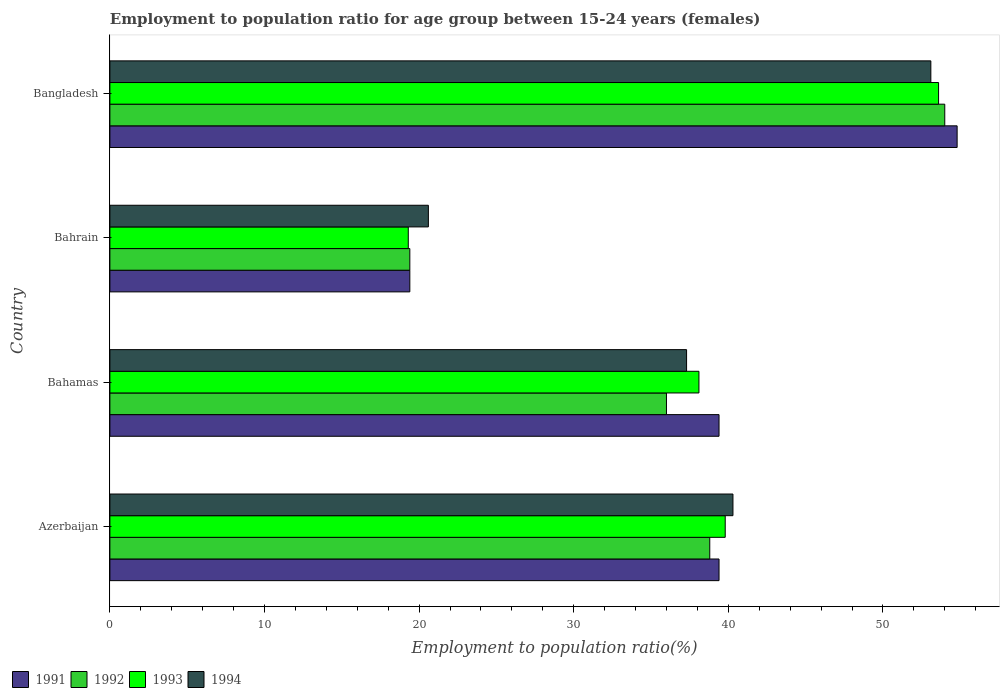What is the label of the 4th group of bars from the top?
Make the answer very short. Azerbaijan. In how many cases, is the number of bars for a given country not equal to the number of legend labels?
Make the answer very short. 0. What is the employment to population ratio in 1994 in Bangladesh?
Ensure brevity in your answer.  53.1. Across all countries, what is the minimum employment to population ratio in 1992?
Offer a very short reply. 19.4. In which country was the employment to population ratio in 1992 maximum?
Your response must be concise. Bangladesh. In which country was the employment to population ratio in 1993 minimum?
Your answer should be very brief. Bahrain. What is the total employment to population ratio in 1992 in the graph?
Ensure brevity in your answer.  148.2. What is the difference between the employment to population ratio in 1993 in Bahrain and that in Bangladesh?
Your answer should be compact. -34.3. What is the difference between the employment to population ratio in 1994 in Bahrain and the employment to population ratio in 1992 in Bangladesh?
Your answer should be compact. -33.4. What is the average employment to population ratio in 1993 per country?
Your answer should be very brief. 37.7. What is the difference between the employment to population ratio in 1992 and employment to population ratio in 1994 in Bahrain?
Your response must be concise. -1.2. In how many countries, is the employment to population ratio in 1994 greater than 20 %?
Your response must be concise. 4. What is the ratio of the employment to population ratio in 1992 in Azerbaijan to that in Bahrain?
Keep it short and to the point. 2. Is the employment to population ratio in 1994 in Azerbaijan less than that in Bahamas?
Give a very brief answer. No. What is the difference between the highest and the second highest employment to population ratio in 1992?
Keep it short and to the point. 15.2. What is the difference between the highest and the lowest employment to population ratio in 1993?
Make the answer very short. 34.3. Is the sum of the employment to population ratio in 1993 in Azerbaijan and Bahrain greater than the maximum employment to population ratio in 1992 across all countries?
Your response must be concise. Yes. What does the 4th bar from the bottom in Bangladesh represents?
Offer a very short reply. 1994. How many bars are there?
Offer a terse response. 16. Are all the bars in the graph horizontal?
Provide a succinct answer. Yes. How many countries are there in the graph?
Give a very brief answer. 4. Does the graph contain grids?
Provide a short and direct response. No. Where does the legend appear in the graph?
Keep it short and to the point. Bottom left. How many legend labels are there?
Provide a short and direct response. 4. What is the title of the graph?
Your answer should be compact. Employment to population ratio for age group between 15-24 years (females). What is the label or title of the X-axis?
Keep it short and to the point. Employment to population ratio(%). What is the Employment to population ratio(%) of 1991 in Azerbaijan?
Ensure brevity in your answer.  39.4. What is the Employment to population ratio(%) of 1992 in Azerbaijan?
Keep it short and to the point. 38.8. What is the Employment to population ratio(%) of 1993 in Azerbaijan?
Your answer should be very brief. 39.8. What is the Employment to population ratio(%) of 1994 in Azerbaijan?
Ensure brevity in your answer.  40.3. What is the Employment to population ratio(%) of 1991 in Bahamas?
Provide a succinct answer. 39.4. What is the Employment to population ratio(%) in 1993 in Bahamas?
Your response must be concise. 38.1. What is the Employment to population ratio(%) in 1994 in Bahamas?
Your response must be concise. 37.3. What is the Employment to population ratio(%) of 1991 in Bahrain?
Your answer should be compact. 19.4. What is the Employment to population ratio(%) of 1992 in Bahrain?
Offer a terse response. 19.4. What is the Employment to population ratio(%) in 1993 in Bahrain?
Provide a short and direct response. 19.3. What is the Employment to population ratio(%) of 1994 in Bahrain?
Provide a succinct answer. 20.6. What is the Employment to population ratio(%) of 1991 in Bangladesh?
Keep it short and to the point. 54.8. What is the Employment to population ratio(%) of 1992 in Bangladesh?
Provide a short and direct response. 54. What is the Employment to population ratio(%) of 1993 in Bangladesh?
Provide a short and direct response. 53.6. What is the Employment to population ratio(%) in 1994 in Bangladesh?
Your answer should be very brief. 53.1. Across all countries, what is the maximum Employment to population ratio(%) in 1991?
Make the answer very short. 54.8. Across all countries, what is the maximum Employment to population ratio(%) of 1992?
Provide a short and direct response. 54. Across all countries, what is the maximum Employment to population ratio(%) in 1993?
Ensure brevity in your answer.  53.6. Across all countries, what is the maximum Employment to population ratio(%) of 1994?
Your answer should be very brief. 53.1. Across all countries, what is the minimum Employment to population ratio(%) of 1991?
Provide a succinct answer. 19.4. Across all countries, what is the minimum Employment to population ratio(%) in 1992?
Offer a very short reply. 19.4. Across all countries, what is the minimum Employment to population ratio(%) of 1993?
Keep it short and to the point. 19.3. Across all countries, what is the minimum Employment to population ratio(%) of 1994?
Offer a very short reply. 20.6. What is the total Employment to population ratio(%) in 1991 in the graph?
Offer a very short reply. 153. What is the total Employment to population ratio(%) in 1992 in the graph?
Provide a succinct answer. 148.2. What is the total Employment to population ratio(%) of 1993 in the graph?
Keep it short and to the point. 150.8. What is the total Employment to population ratio(%) in 1994 in the graph?
Your response must be concise. 151.3. What is the difference between the Employment to population ratio(%) of 1991 in Azerbaijan and that in Bahamas?
Your answer should be very brief. 0. What is the difference between the Employment to population ratio(%) in 1994 in Azerbaijan and that in Bahamas?
Make the answer very short. 3. What is the difference between the Employment to population ratio(%) in 1992 in Azerbaijan and that in Bahrain?
Ensure brevity in your answer.  19.4. What is the difference between the Employment to population ratio(%) of 1994 in Azerbaijan and that in Bahrain?
Make the answer very short. 19.7. What is the difference between the Employment to population ratio(%) of 1991 in Azerbaijan and that in Bangladesh?
Give a very brief answer. -15.4. What is the difference between the Employment to population ratio(%) in 1992 in Azerbaijan and that in Bangladesh?
Offer a terse response. -15.2. What is the difference between the Employment to population ratio(%) of 1991 in Bahamas and that in Bahrain?
Your answer should be very brief. 20. What is the difference between the Employment to population ratio(%) in 1992 in Bahamas and that in Bahrain?
Keep it short and to the point. 16.6. What is the difference between the Employment to population ratio(%) of 1993 in Bahamas and that in Bahrain?
Make the answer very short. 18.8. What is the difference between the Employment to population ratio(%) in 1991 in Bahamas and that in Bangladesh?
Your response must be concise. -15.4. What is the difference between the Employment to population ratio(%) of 1992 in Bahamas and that in Bangladesh?
Keep it short and to the point. -18. What is the difference between the Employment to population ratio(%) in 1993 in Bahamas and that in Bangladesh?
Provide a short and direct response. -15.5. What is the difference between the Employment to population ratio(%) of 1994 in Bahamas and that in Bangladesh?
Ensure brevity in your answer.  -15.8. What is the difference between the Employment to population ratio(%) in 1991 in Bahrain and that in Bangladesh?
Offer a very short reply. -35.4. What is the difference between the Employment to population ratio(%) in 1992 in Bahrain and that in Bangladesh?
Provide a short and direct response. -34.6. What is the difference between the Employment to population ratio(%) in 1993 in Bahrain and that in Bangladesh?
Provide a succinct answer. -34.3. What is the difference between the Employment to population ratio(%) of 1994 in Bahrain and that in Bangladesh?
Make the answer very short. -32.5. What is the difference between the Employment to population ratio(%) of 1991 in Azerbaijan and the Employment to population ratio(%) of 1992 in Bahamas?
Make the answer very short. 3.4. What is the difference between the Employment to population ratio(%) in 1991 in Azerbaijan and the Employment to population ratio(%) in 1994 in Bahamas?
Keep it short and to the point. 2.1. What is the difference between the Employment to population ratio(%) in 1993 in Azerbaijan and the Employment to population ratio(%) in 1994 in Bahamas?
Ensure brevity in your answer.  2.5. What is the difference between the Employment to population ratio(%) in 1991 in Azerbaijan and the Employment to population ratio(%) in 1992 in Bahrain?
Your answer should be compact. 20. What is the difference between the Employment to population ratio(%) in 1991 in Azerbaijan and the Employment to population ratio(%) in 1993 in Bahrain?
Provide a succinct answer. 20.1. What is the difference between the Employment to population ratio(%) in 1991 in Azerbaijan and the Employment to population ratio(%) in 1994 in Bahrain?
Make the answer very short. 18.8. What is the difference between the Employment to population ratio(%) in 1992 in Azerbaijan and the Employment to population ratio(%) in 1993 in Bahrain?
Provide a succinct answer. 19.5. What is the difference between the Employment to population ratio(%) of 1992 in Azerbaijan and the Employment to population ratio(%) of 1994 in Bahrain?
Your answer should be very brief. 18.2. What is the difference between the Employment to population ratio(%) in 1991 in Azerbaijan and the Employment to population ratio(%) in 1992 in Bangladesh?
Provide a short and direct response. -14.6. What is the difference between the Employment to population ratio(%) in 1991 in Azerbaijan and the Employment to population ratio(%) in 1994 in Bangladesh?
Give a very brief answer. -13.7. What is the difference between the Employment to population ratio(%) of 1992 in Azerbaijan and the Employment to population ratio(%) of 1993 in Bangladesh?
Offer a very short reply. -14.8. What is the difference between the Employment to population ratio(%) in 1992 in Azerbaijan and the Employment to population ratio(%) in 1994 in Bangladesh?
Make the answer very short. -14.3. What is the difference between the Employment to population ratio(%) of 1991 in Bahamas and the Employment to population ratio(%) of 1993 in Bahrain?
Keep it short and to the point. 20.1. What is the difference between the Employment to population ratio(%) in 1991 in Bahamas and the Employment to population ratio(%) in 1994 in Bahrain?
Offer a very short reply. 18.8. What is the difference between the Employment to population ratio(%) in 1992 in Bahamas and the Employment to population ratio(%) in 1993 in Bahrain?
Keep it short and to the point. 16.7. What is the difference between the Employment to population ratio(%) of 1992 in Bahamas and the Employment to population ratio(%) of 1994 in Bahrain?
Keep it short and to the point. 15.4. What is the difference between the Employment to population ratio(%) of 1993 in Bahamas and the Employment to population ratio(%) of 1994 in Bahrain?
Make the answer very short. 17.5. What is the difference between the Employment to population ratio(%) in 1991 in Bahamas and the Employment to population ratio(%) in 1992 in Bangladesh?
Your answer should be very brief. -14.6. What is the difference between the Employment to population ratio(%) of 1991 in Bahamas and the Employment to population ratio(%) of 1993 in Bangladesh?
Your answer should be compact. -14.2. What is the difference between the Employment to population ratio(%) in 1991 in Bahamas and the Employment to population ratio(%) in 1994 in Bangladesh?
Your answer should be compact. -13.7. What is the difference between the Employment to population ratio(%) of 1992 in Bahamas and the Employment to population ratio(%) of 1993 in Bangladesh?
Your answer should be compact. -17.6. What is the difference between the Employment to population ratio(%) in 1992 in Bahamas and the Employment to population ratio(%) in 1994 in Bangladesh?
Provide a succinct answer. -17.1. What is the difference between the Employment to population ratio(%) of 1993 in Bahamas and the Employment to population ratio(%) of 1994 in Bangladesh?
Make the answer very short. -15. What is the difference between the Employment to population ratio(%) in 1991 in Bahrain and the Employment to population ratio(%) in 1992 in Bangladesh?
Provide a succinct answer. -34.6. What is the difference between the Employment to population ratio(%) of 1991 in Bahrain and the Employment to population ratio(%) of 1993 in Bangladesh?
Your response must be concise. -34.2. What is the difference between the Employment to population ratio(%) of 1991 in Bahrain and the Employment to population ratio(%) of 1994 in Bangladesh?
Offer a very short reply. -33.7. What is the difference between the Employment to population ratio(%) in 1992 in Bahrain and the Employment to population ratio(%) in 1993 in Bangladesh?
Make the answer very short. -34.2. What is the difference between the Employment to population ratio(%) in 1992 in Bahrain and the Employment to population ratio(%) in 1994 in Bangladesh?
Ensure brevity in your answer.  -33.7. What is the difference between the Employment to population ratio(%) in 1993 in Bahrain and the Employment to population ratio(%) in 1994 in Bangladesh?
Keep it short and to the point. -33.8. What is the average Employment to population ratio(%) in 1991 per country?
Your answer should be very brief. 38.25. What is the average Employment to population ratio(%) of 1992 per country?
Your response must be concise. 37.05. What is the average Employment to population ratio(%) of 1993 per country?
Give a very brief answer. 37.7. What is the average Employment to population ratio(%) of 1994 per country?
Your response must be concise. 37.83. What is the difference between the Employment to population ratio(%) of 1991 and Employment to population ratio(%) of 1992 in Azerbaijan?
Ensure brevity in your answer.  0.6. What is the difference between the Employment to population ratio(%) in 1991 and Employment to population ratio(%) in 1994 in Azerbaijan?
Your answer should be very brief. -0.9. What is the difference between the Employment to population ratio(%) of 1992 and Employment to population ratio(%) of 1993 in Azerbaijan?
Your answer should be very brief. -1. What is the difference between the Employment to population ratio(%) of 1991 and Employment to population ratio(%) of 1992 in Bahamas?
Make the answer very short. 3.4. What is the difference between the Employment to population ratio(%) in 1992 and Employment to population ratio(%) in 1994 in Bahamas?
Your answer should be very brief. -1.3. What is the difference between the Employment to population ratio(%) of 1993 and Employment to population ratio(%) of 1994 in Bahamas?
Provide a succinct answer. 0.8. What is the difference between the Employment to population ratio(%) in 1991 and Employment to population ratio(%) in 1992 in Bahrain?
Keep it short and to the point. 0. What is the difference between the Employment to population ratio(%) of 1992 and Employment to population ratio(%) of 1993 in Bahrain?
Your answer should be compact. 0.1. What is the difference between the Employment to population ratio(%) in 1992 and Employment to population ratio(%) in 1994 in Bahrain?
Give a very brief answer. -1.2. What is the difference between the Employment to population ratio(%) of 1993 and Employment to population ratio(%) of 1994 in Bahrain?
Provide a succinct answer. -1.3. What is the difference between the Employment to population ratio(%) in 1991 and Employment to population ratio(%) in 1992 in Bangladesh?
Offer a terse response. 0.8. What is the difference between the Employment to population ratio(%) of 1991 and Employment to population ratio(%) of 1994 in Bangladesh?
Provide a short and direct response. 1.7. What is the difference between the Employment to population ratio(%) of 1992 and Employment to population ratio(%) of 1994 in Bangladesh?
Your answer should be compact. 0.9. What is the difference between the Employment to population ratio(%) of 1993 and Employment to population ratio(%) of 1994 in Bangladesh?
Your response must be concise. 0.5. What is the ratio of the Employment to population ratio(%) in 1992 in Azerbaijan to that in Bahamas?
Your response must be concise. 1.08. What is the ratio of the Employment to population ratio(%) in 1993 in Azerbaijan to that in Bahamas?
Ensure brevity in your answer.  1.04. What is the ratio of the Employment to population ratio(%) in 1994 in Azerbaijan to that in Bahamas?
Offer a terse response. 1.08. What is the ratio of the Employment to population ratio(%) in 1991 in Azerbaijan to that in Bahrain?
Offer a very short reply. 2.03. What is the ratio of the Employment to population ratio(%) in 1993 in Azerbaijan to that in Bahrain?
Make the answer very short. 2.06. What is the ratio of the Employment to population ratio(%) in 1994 in Azerbaijan to that in Bahrain?
Your response must be concise. 1.96. What is the ratio of the Employment to population ratio(%) of 1991 in Azerbaijan to that in Bangladesh?
Offer a terse response. 0.72. What is the ratio of the Employment to population ratio(%) of 1992 in Azerbaijan to that in Bangladesh?
Your answer should be compact. 0.72. What is the ratio of the Employment to population ratio(%) of 1993 in Azerbaijan to that in Bangladesh?
Make the answer very short. 0.74. What is the ratio of the Employment to population ratio(%) in 1994 in Azerbaijan to that in Bangladesh?
Give a very brief answer. 0.76. What is the ratio of the Employment to population ratio(%) of 1991 in Bahamas to that in Bahrain?
Offer a very short reply. 2.03. What is the ratio of the Employment to population ratio(%) of 1992 in Bahamas to that in Bahrain?
Make the answer very short. 1.86. What is the ratio of the Employment to population ratio(%) of 1993 in Bahamas to that in Bahrain?
Make the answer very short. 1.97. What is the ratio of the Employment to population ratio(%) of 1994 in Bahamas to that in Bahrain?
Give a very brief answer. 1.81. What is the ratio of the Employment to population ratio(%) of 1991 in Bahamas to that in Bangladesh?
Your answer should be very brief. 0.72. What is the ratio of the Employment to population ratio(%) in 1993 in Bahamas to that in Bangladesh?
Offer a terse response. 0.71. What is the ratio of the Employment to population ratio(%) in 1994 in Bahamas to that in Bangladesh?
Offer a terse response. 0.7. What is the ratio of the Employment to population ratio(%) in 1991 in Bahrain to that in Bangladesh?
Your answer should be very brief. 0.35. What is the ratio of the Employment to population ratio(%) of 1992 in Bahrain to that in Bangladesh?
Your answer should be compact. 0.36. What is the ratio of the Employment to population ratio(%) of 1993 in Bahrain to that in Bangladesh?
Your response must be concise. 0.36. What is the ratio of the Employment to population ratio(%) in 1994 in Bahrain to that in Bangladesh?
Give a very brief answer. 0.39. What is the difference between the highest and the second highest Employment to population ratio(%) in 1991?
Provide a succinct answer. 15.4. What is the difference between the highest and the second highest Employment to population ratio(%) of 1993?
Your answer should be compact. 13.8. What is the difference between the highest and the lowest Employment to population ratio(%) in 1991?
Keep it short and to the point. 35.4. What is the difference between the highest and the lowest Employment to population ratio(%) in 1992?
Your response must be concise. 34.6. What is the difference between the highest and the lowest Employment to population ratio(%) of 1993?
Your response must be concise. 34.3. What is the difference between the highest and the lowest Employment to population ratio(%) of 1994?
Your answer should be very brief. 32.5. 